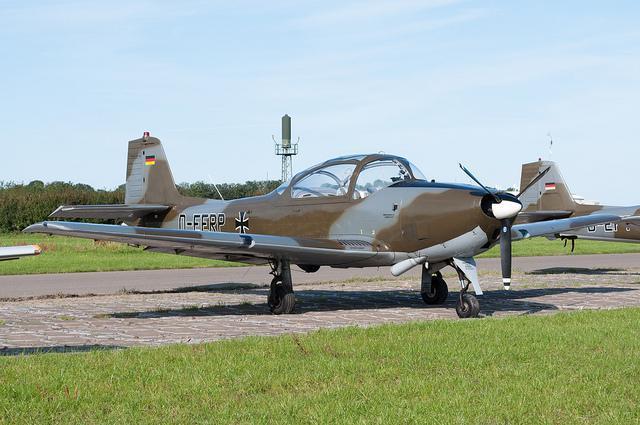How many airplanes are there?
Give a very brief answer. 2. 